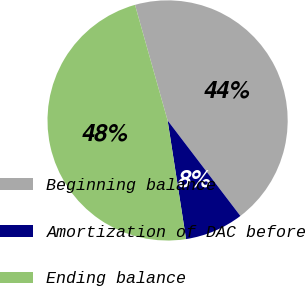Convert chart. <chart><loc_0><loc_0><loc_500><loc_500><pie_chart><fcel>Beginning balance<fcel>Amortization of DAC before<fcel>Ending balance<nl><fcel>44.01%<fcel>7.91%<fcel>48.08%<nl></chart> 